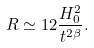Convert formula to latex. <formula><loc_0><loc_0><loc_500><loc_500>R \simeq 1 2 \frac { H _ { 0 } ^ { 2 } } { t ^ { 2 \beta } } .</formula> 